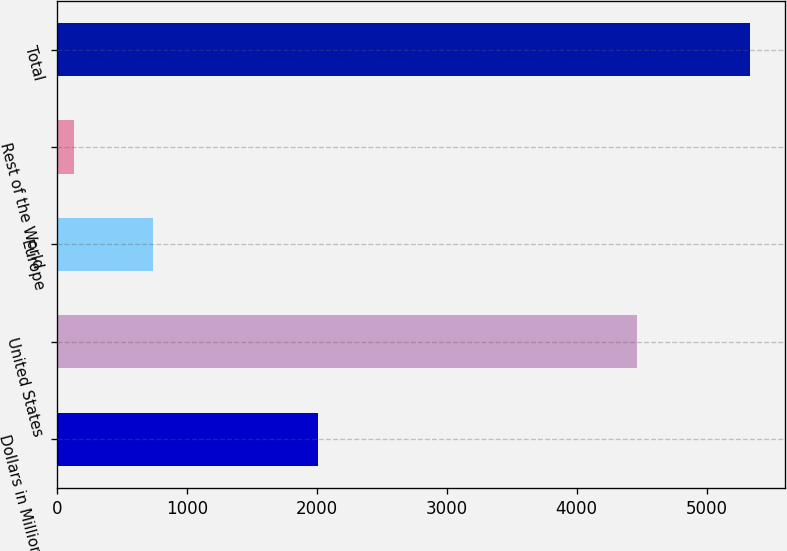Convert chart. <chart><loc_0><loc_0><loc_500><loc_500><bar_chart><fcel>Dollars in Millions<fcel>United States<fcel>Europe<fcel>Rest of the World<fcel>Total<nl><fcel>2012<fcel>4464<fcel>740<fcel>129<fcel>5333<nl></chart> 